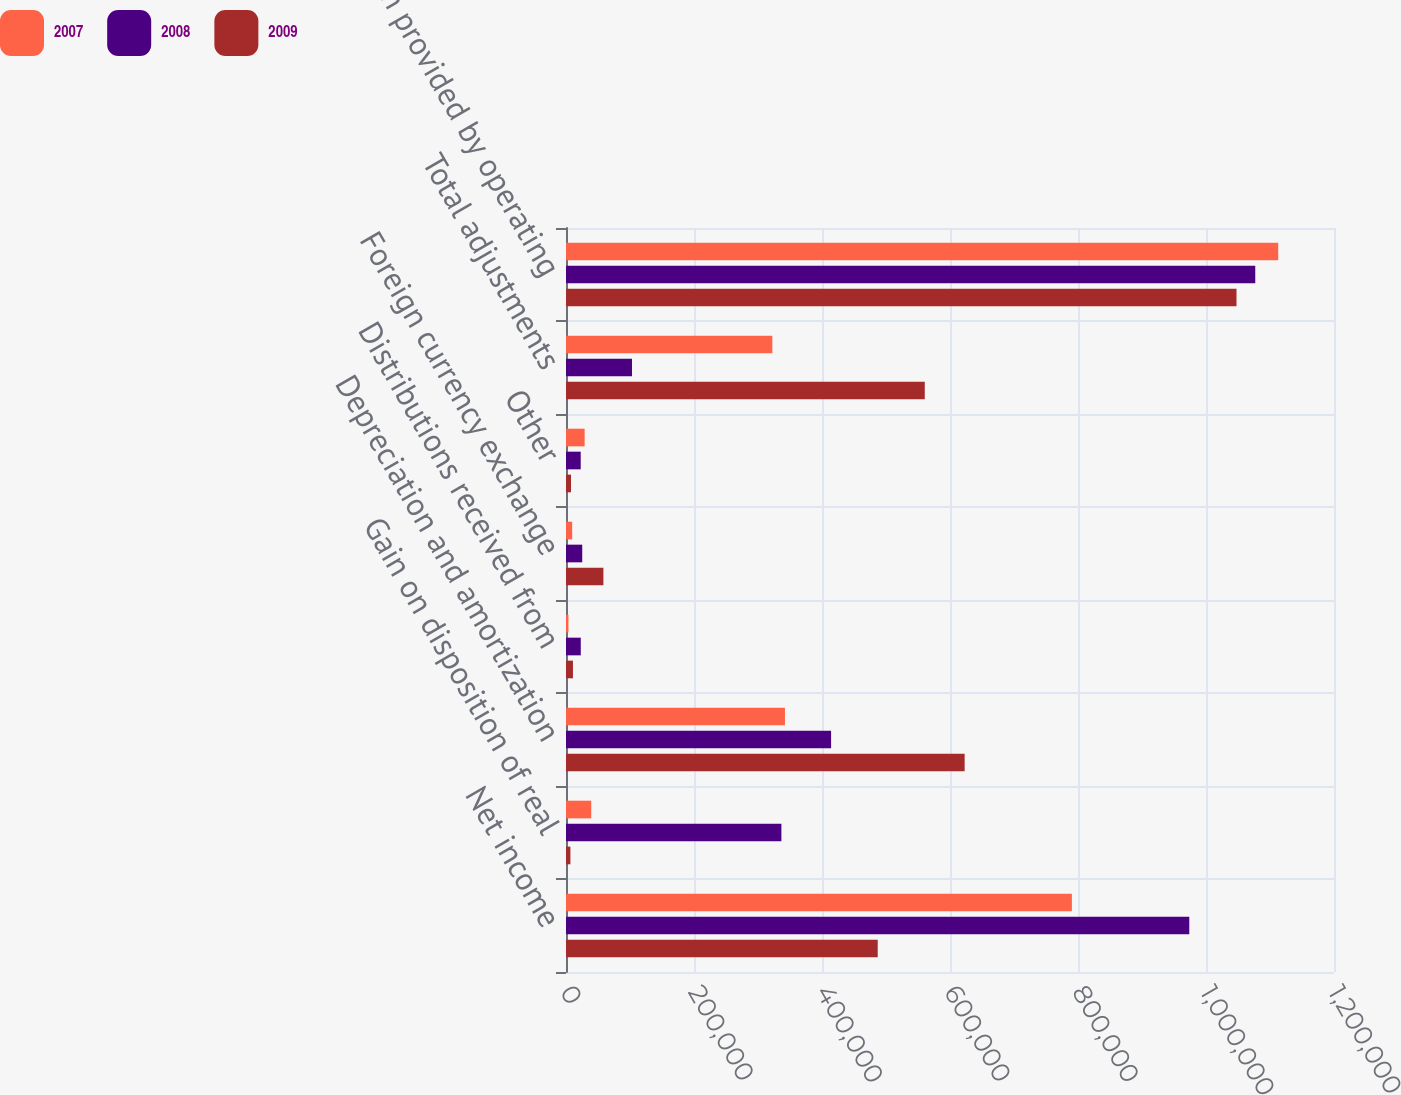Convert chart to OTSL. <chart><loc_0><loc_0><loc_500><loc_500><stacked_bar_chart><ecel><fcel>Net income<fcel>Gain on disposition of real<fcel>Depreciation and amortization<fcel>Distributions received from<fcel>Foreign currency exchange<fcel>Other<fcel>Total adjustments<fcel>Net cash provided by operating<nl><fcel>2007<fcel>790456<fcel>39444<fcel>342127<fcel>3836<fcel>9662<fcel>29125<fcel>322401<fcel>1.11286e+06<nl><fcel>2008<fcel>973872<fcel>336545<fcel>414201<fcel>23064<fcel>25362<fcel>22983<fcel>103099<fcel>1.07697e+06<nl><fcel>2009<fcel>487078<fcel>6883<fcel>622894<fcel>10868<fcel>58444<fcel>7861<fcel>560574<fcel>1.04765e+06<nl></chart> 